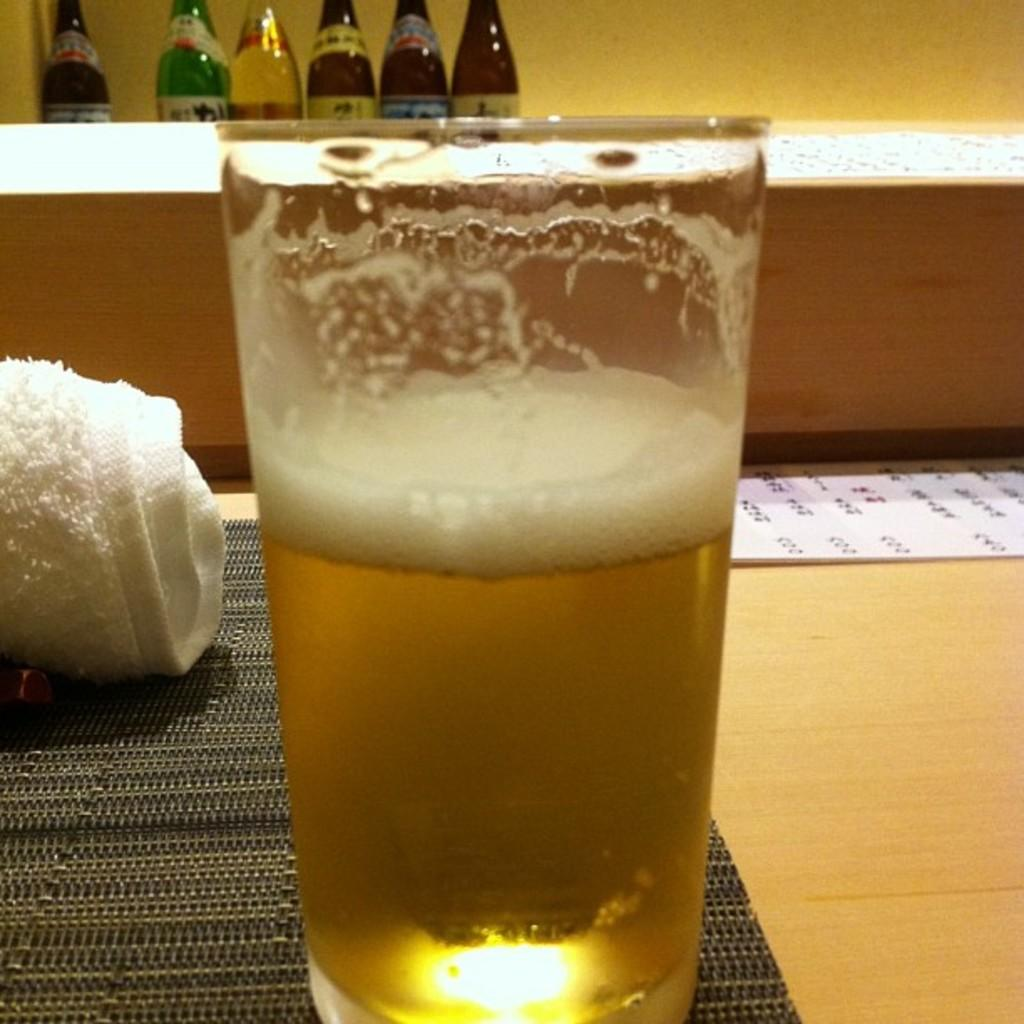What is in the glass that is visible in the image? There is a glass with wine in the image. Where is the glass placed in the image? The glass is placed on the floor in the image. What is wrapped behind the glass? There is a cloth wrapped behind the glass. What can be seen on the desk behind the cloth? There are bottles placed on a desk behind the cloth. What type of rhythm can be heard coming from the glass in the image? There is no rhythm associated with the glass in the image, as it is a still object containing wine. 